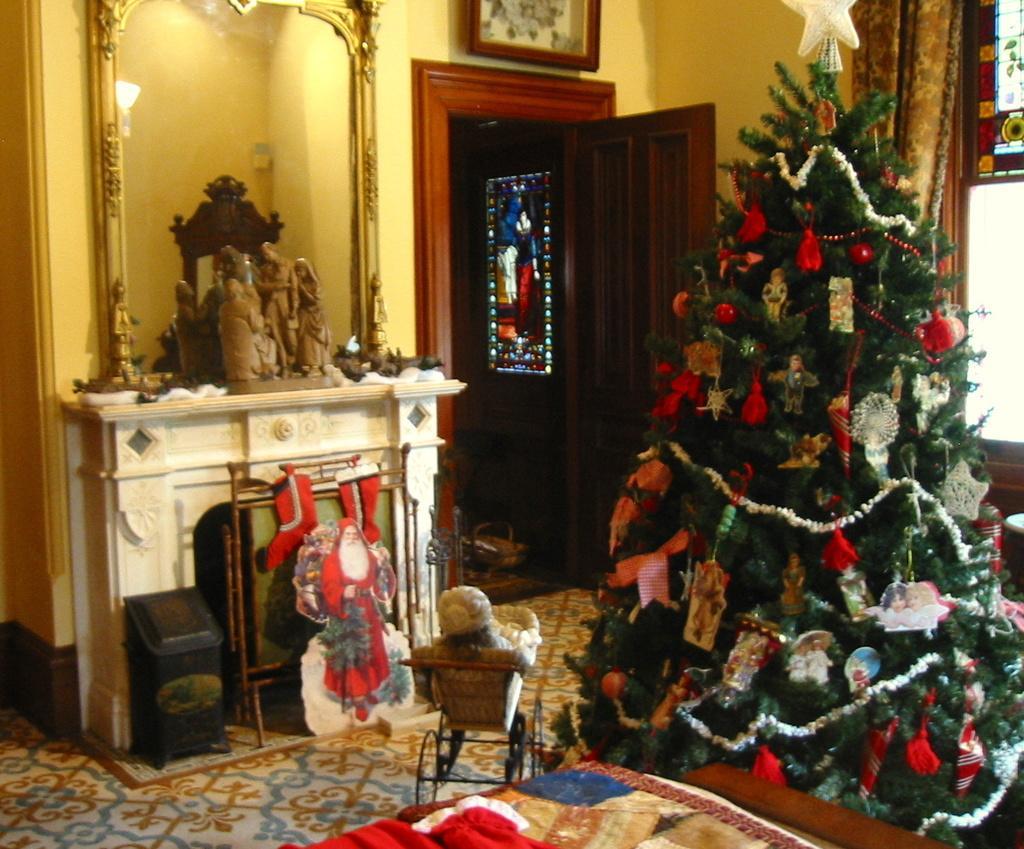Can you describe this image briefly? This image is taken in the room. In the center of the image there is a door and we can see an xmas tree decorated with balls and decors. On the left there is a mirror. In the background there is a wall and a curtain. We can see frames placed on the wall. There is a sculpture placed on the stand. 